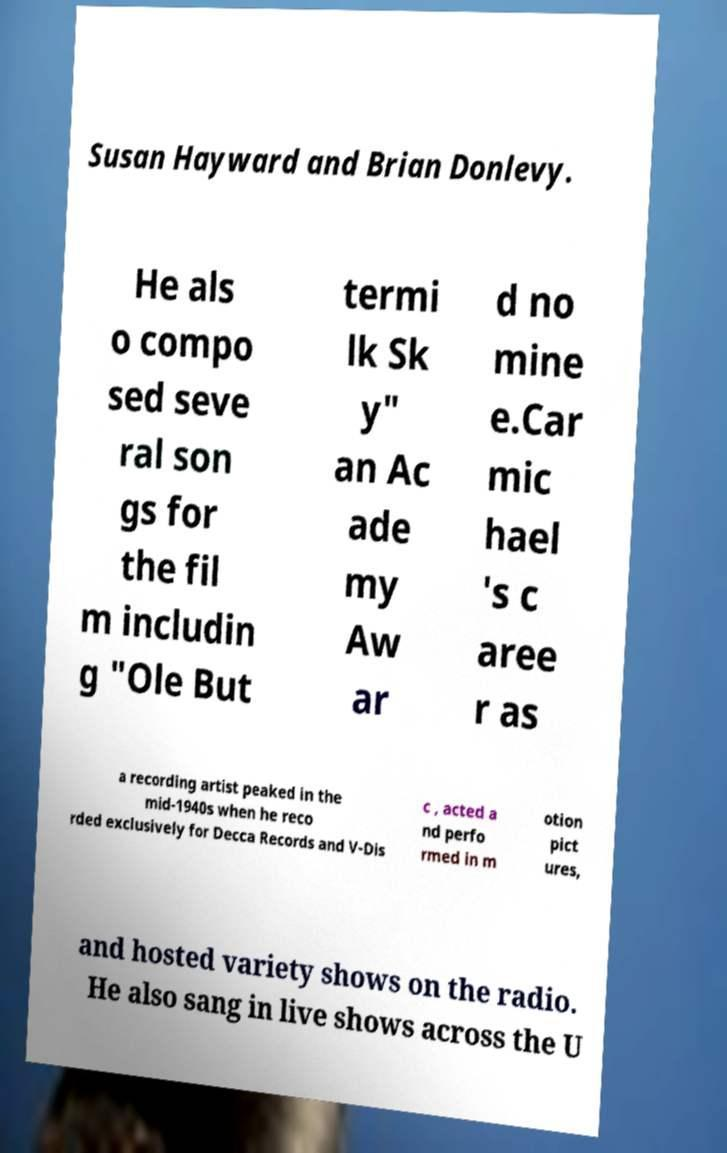Could you assist in decoding the text presented in this image and type it out clearly? Susan Hayward and Brian Donlevy. He als o compo sed seve ral son gs for the fil m includin g "Ole But termi lk Sk y" an Ac ade my Aw ar d no mine e.Car mic hael 's c aree r as a recording artist peaked in the mid-1940s when he reco rded exclusively for Decca Records and V-Dis c , acted a nd perfo rmed in m otion pict ures, and hosted variety shows on the radio. He also sang in live shows across the U 